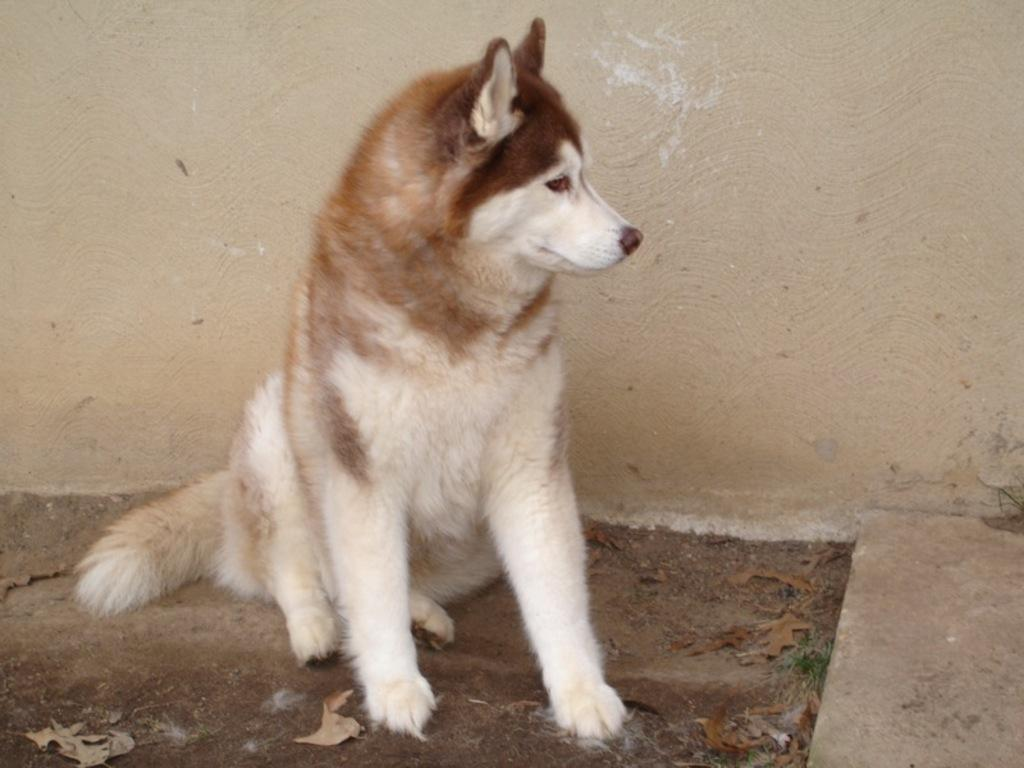What type of animal is in the image? There is a white and brown color dog in the image. Where is the dog positioned in the image? The dog is in the front of the image. What can be seen in the background of the image? There is a wall in the background of the image. What is on the ground in the image? There are leaves on the ground in the image. What type of art is the dog creating with its thumb in the image? There is no art or thumb present in the image; it features a dog in the front of the image with a wall in the background and leaves on the ground. 